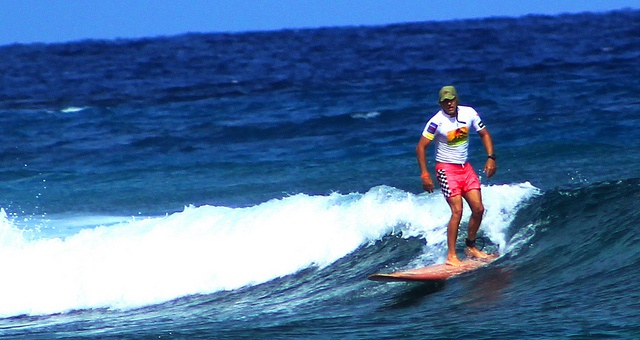Describe the objects in this image and their specific colors. I can see people in lightblue, white, navy, blue, and maroon tones, surfboard in lightblue, lightpink, black, tan, and brown tones, and clock in black and lightblue tones in this image. 